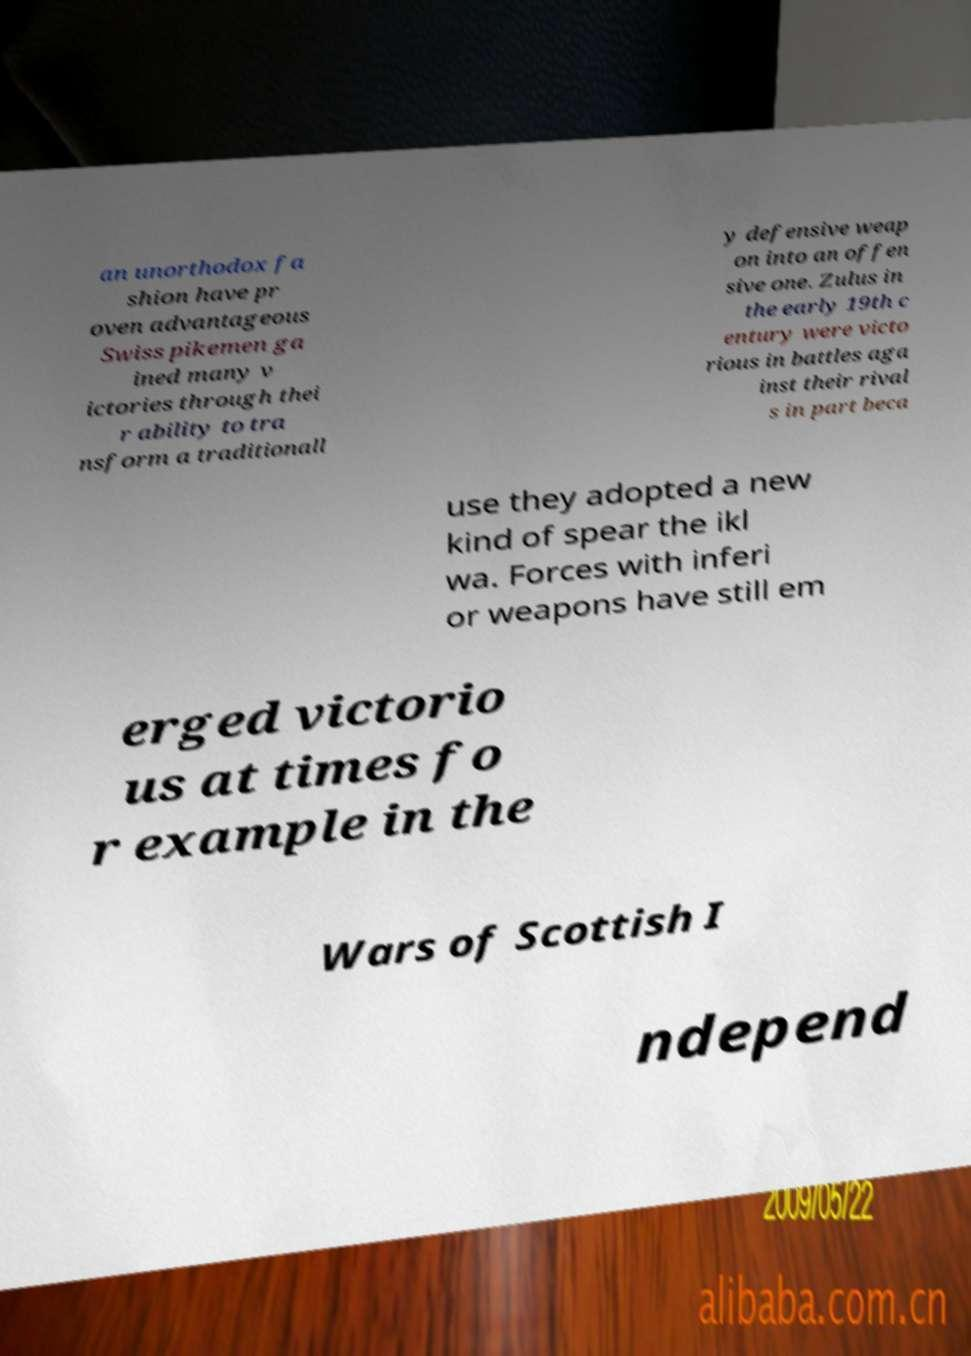Can you read and provide the text displayed in the image?This photo seems to have some interesting text. Can you extract and type it out for me? an unorthodox fa shion have pr oven advantageous Swiss pikemen ga ined many v ictories through thei r ability to tra nsform a traditionall y defensive weap on into an offen sive one. Zulus in the early 19th c entury were victo rious in battles aga inst their rival s in part beca use they adopted a new kind of spear the ikl wa. Forces with inferi or weapons have still em erged victorio us at times fo r example in the Wars of Scottish I ndepend 